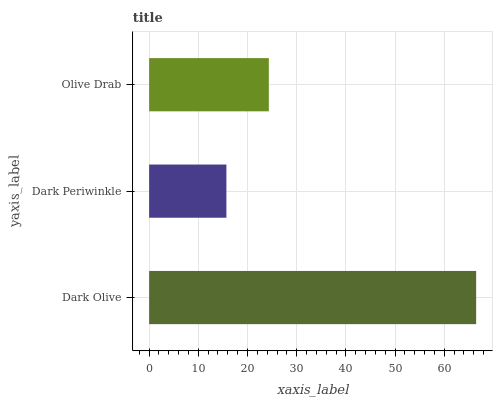Is Dark Periwinkle the minimum?
Answer yes or no. Yes. Is Dark Olive the maximum?
Answer yes or no. Yes. Is Olive Drab the minimum?
Answer yes or no. No. Is Olive Drab the maximum?
Answer yes or no. No. Is Olive Drab greater than Dark Periwinkle?
Answer yes or no. Yes. Is Dark Periwinkle less than Olive Drab?
Answer yes or no. Yes. Is Dark Periwinkle greater than Olive Drab?
Answer yes or no. No. Is Olive Drab less than Dark Periwinkle?
Answer yes or no. No. Is Olive Drab the high median?
Answer yes or no. Yes. Is Olive Drab the low median?
Answer yes or no. Yes. Is Dark Periwinkle the high median?
Answer yes or no. No. Is Dark Olive the low median?
Answer yes or no. No. 